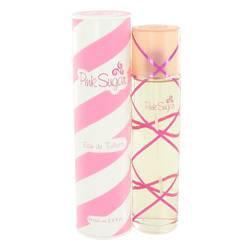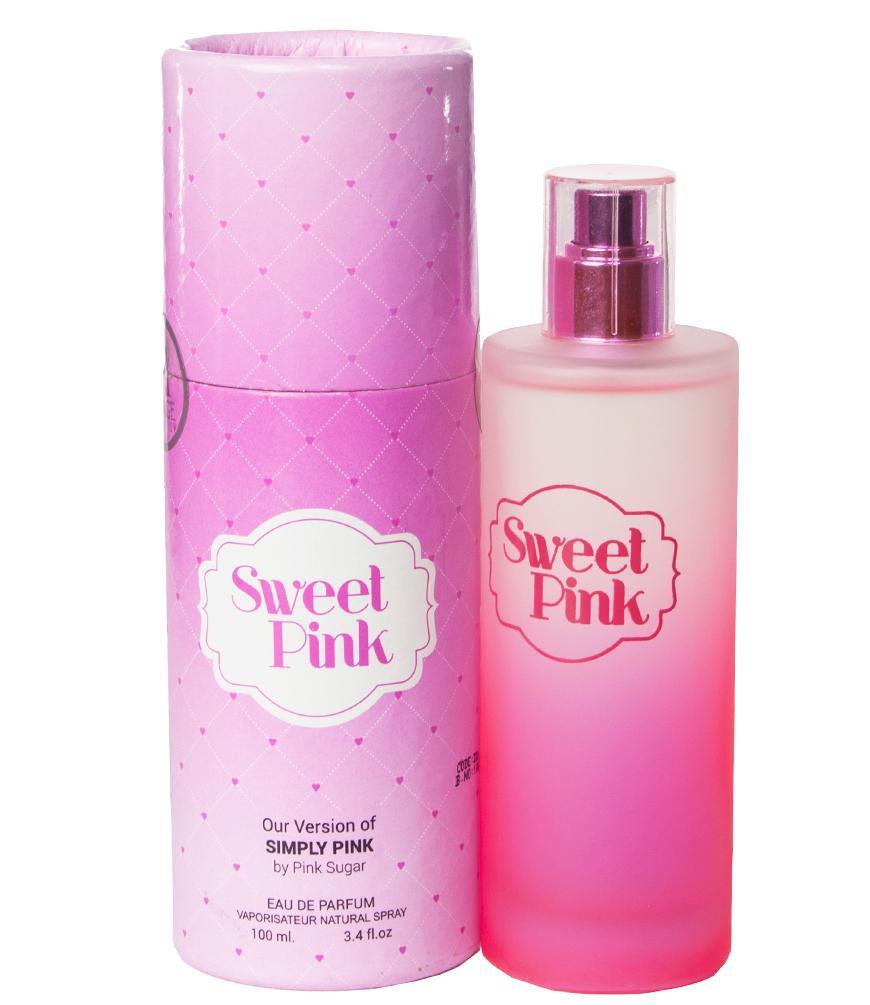The first image is the image on the left, the second image is the image on the right. Given the left and right images, does the statement "At least one bottle has a round ball on top of it." hold true? Answer yes or no. No. The first image is the image on the left, the second image is the image on the right. Considering the images on both sides, is "The left image features a cylindrical bottle with a hot pink rounded cap standing to the right of an upright hot pink box and slightly overlapping it." valid? Answer yes or no. No. 